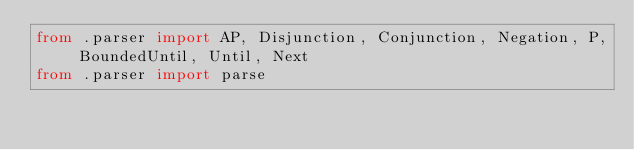Convert code to text. <code><loc_0><loc_0><loc_500><loc_500><_Python_>from .parser import AP, Disjunction, Conjunction, Negation, P, BoundedUntil, Until, Next
from .parser import parse
</code> 